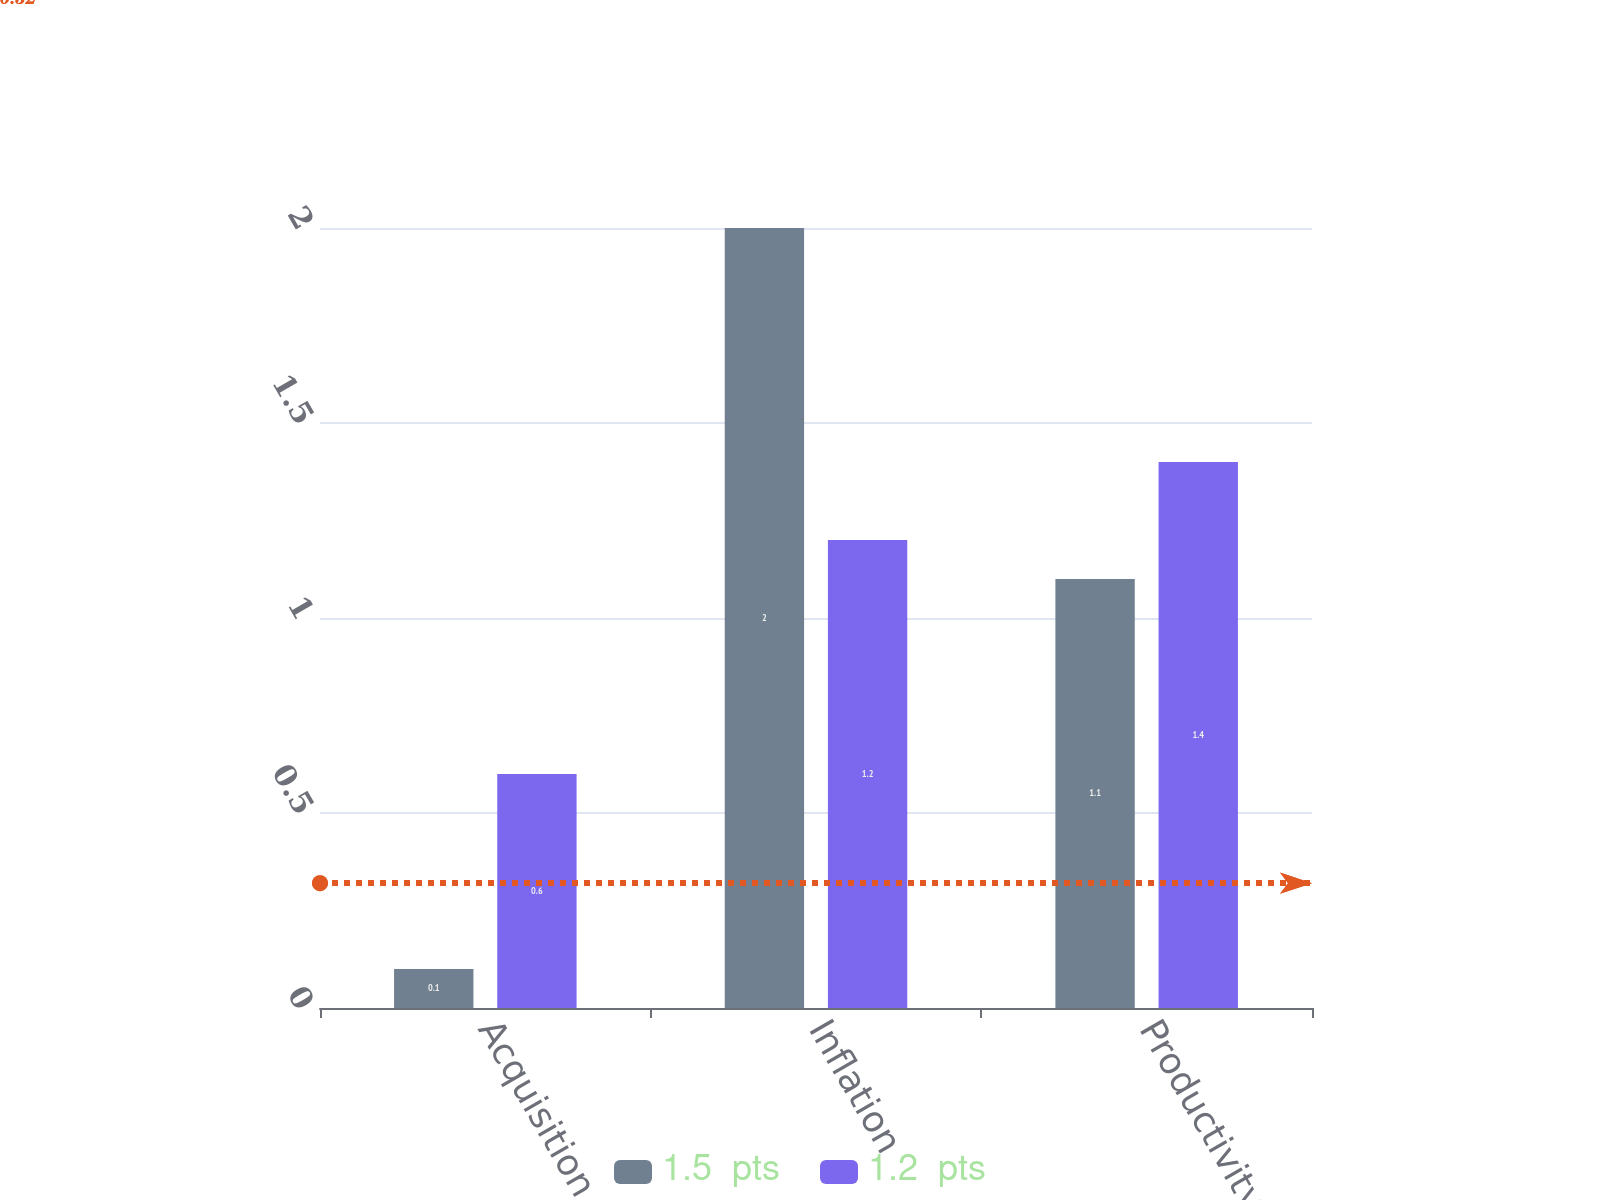<chart> <loc_0><loc_0><loc_500><loc_500><stacked_bar_chart><ecel><fcel>Acquisition<fcel>Inflation<fcel>Productivity/Price<nl><fcel>1.5  pts<fcel>0.1<fcel>2<fcel>1.1<nl><fcel>1.2  pts<fcel>0.6<fcel>1.2<fcel>1.4<nl></chart> 